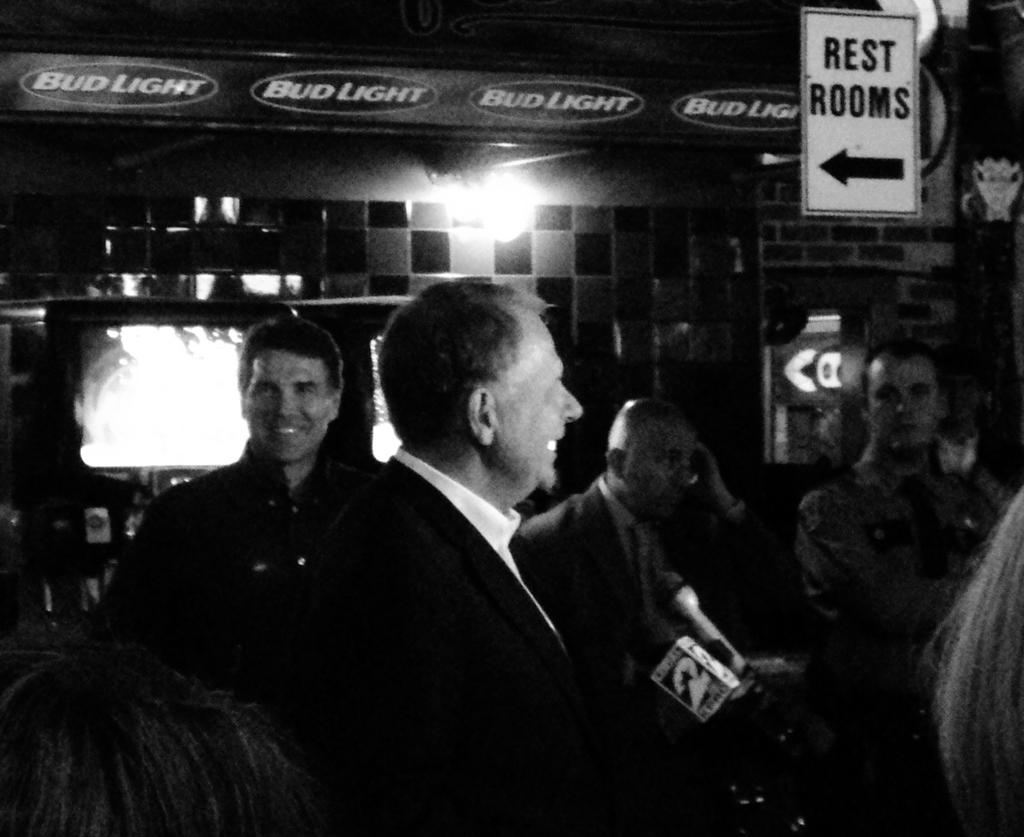What can be seen at the bottom of the image? There are people standing at the bottom of the image. What is the facial expression of the people in the image? The people are smiling. What is located behind the people in the image? There is a wall behind the people. What is attached to the wall in the image? There is a banner and a sign board on the wall. What type of wealth is depicted on the sign board in the image? There is no mention of wealth or any related symbols on the sign board in the image. 